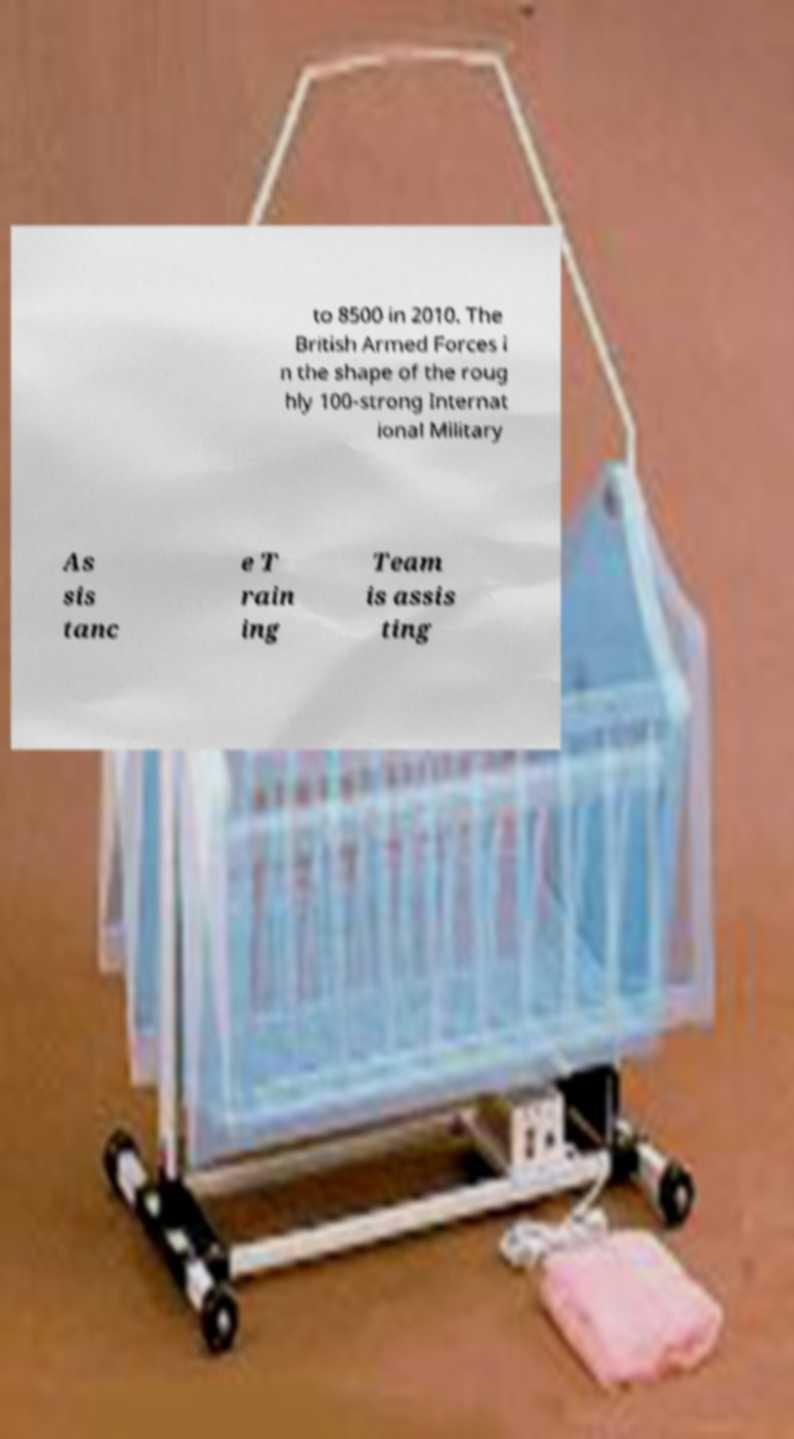What messages or text are displayed in this image? I need them in a readable, typed format. to 8500 in 2010. The British Armed Forces i n the shape of the roug hly 100-strong Internat ional Military As sis tanc e T rain ing Team is assis ting 